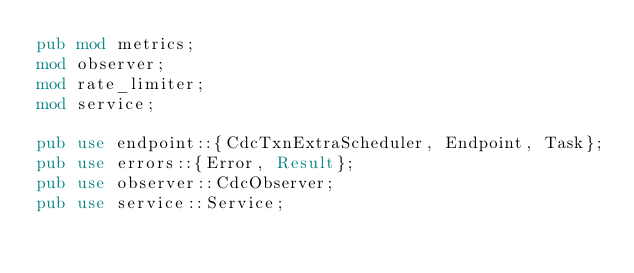<code> <loc_0><loc_0><loc_500><loc_500><_Rust_>pub mod metrics;
mod observer;
mod rate_limiter;
mod service;

pub use endpoint::{CdcTxnExtraScheduler, Endpoint, Task};
pub use errors::{Error, Result};
pub use observer::CdcObserver;
pub use service::Service;
</code> 